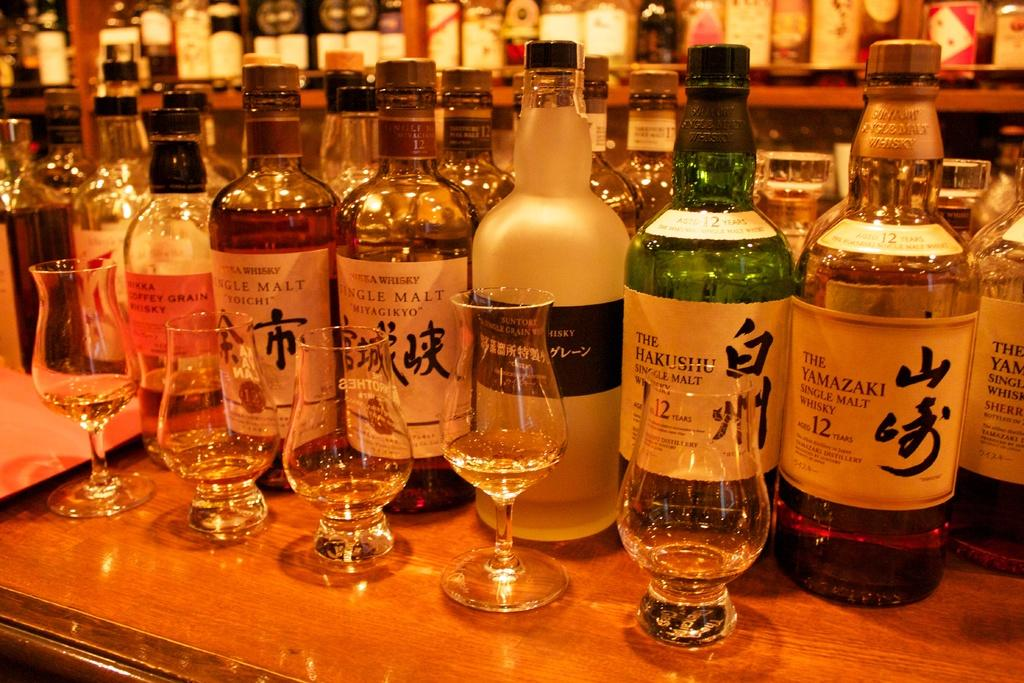<image>
Share a concise interpretation of the image provided. bottles of hakushu single malt with empty glasses 